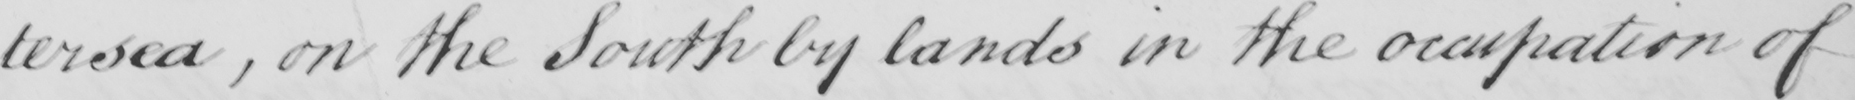What does this handwritten line say? on the South by lands in the occupation of 